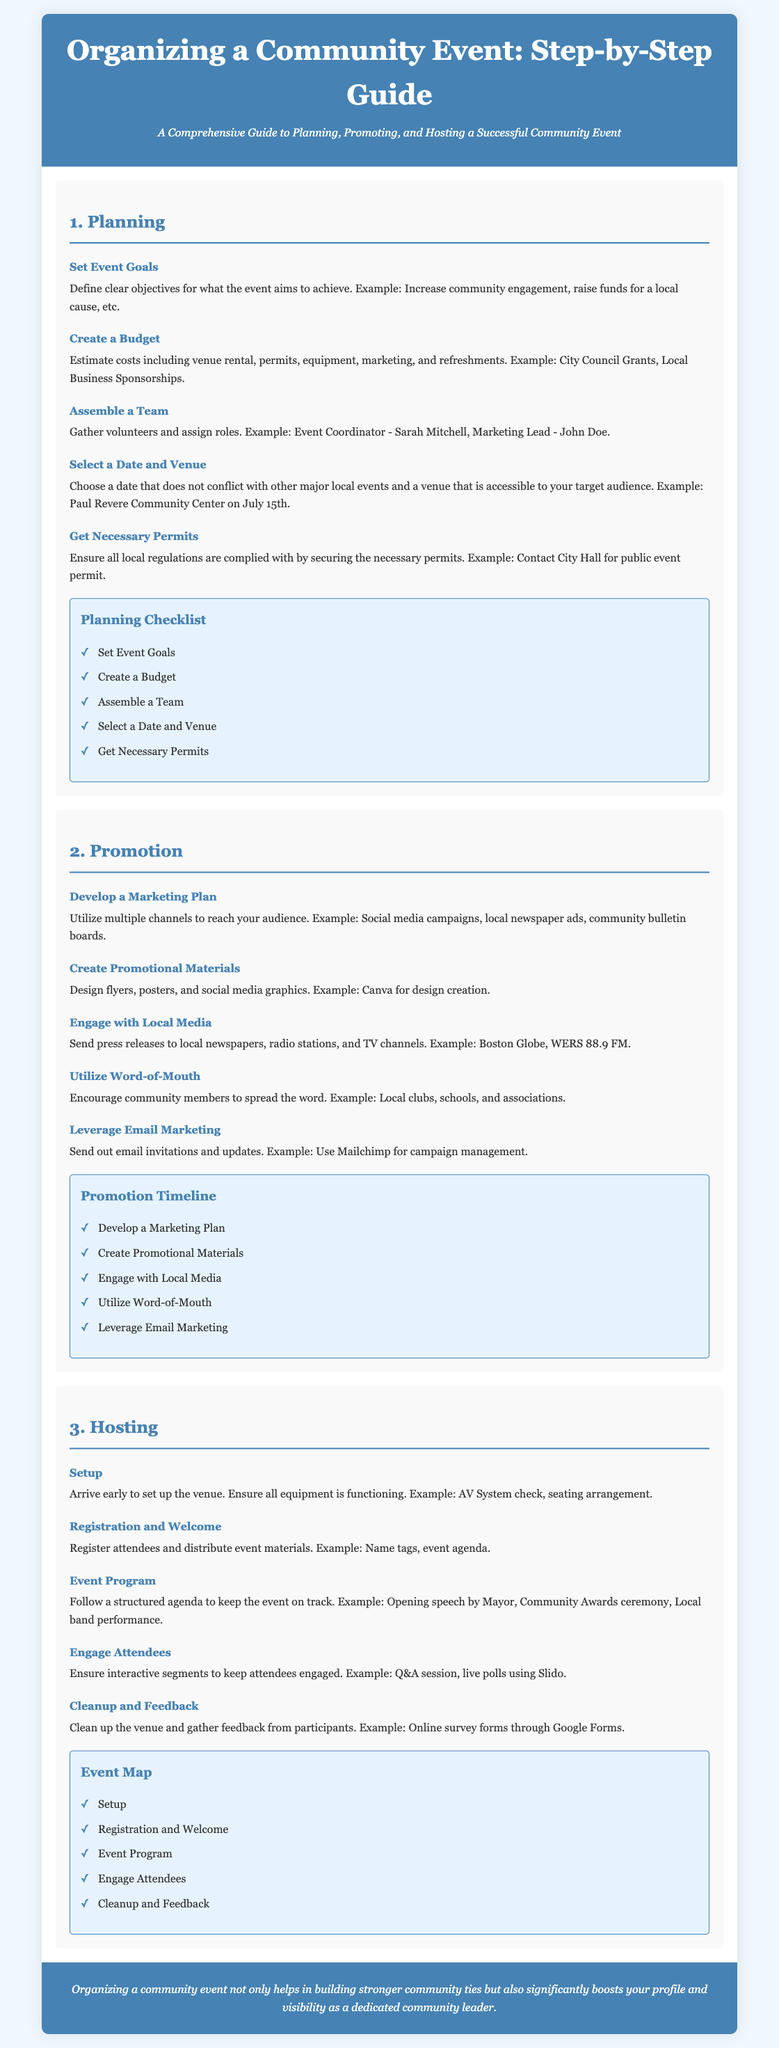what is the first step in organizing a community event? The first step in organizing a community event, as outlined in the document, is to "Set Event Goals".
Answer: Set Event Goals who is responsible for marketing in the preliminary team? The document names John Doe as the Marketing Lead in the team assembly.
Answer: John Doe what is the date of the event mentioned in the planning section? The document specifies the event will be held on July 15th at the Paul Revere Community Center.
Answer: July 15th which platform is suggested for email marketing? The document recommends using Mailchimp for email marketing.
Answer: Mailchimp what should be done to gather feedback from participants after the event? The document suggests gathering feedback through an online survey form.
Answer: Online survey forms what are two promotional channels mentioned for reaching the audience? The document mentions social media campaigns and local newspaper ads as promotional channels.
Answer: social media campaigns, local newspaper ads how many steps are there in the planning checklist? The planning checklist consists of five steps as listed in the document.
Answer: five steps what is a suggested activity to engage attendees during the event? An interactive segment suggested for attendee engagement in the document is a Q&A session.
Answer: Q&A session what is the color of the header background? The background color of the header is specified as #4682b4 in the document's style.
Answer: #4682b4 